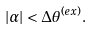Convert formula to latex. <formula><loc_0><loc_0><loc_500><loc_500>| \alpha | < \Delta \theta ^ { ( e x ) } .</formula> 